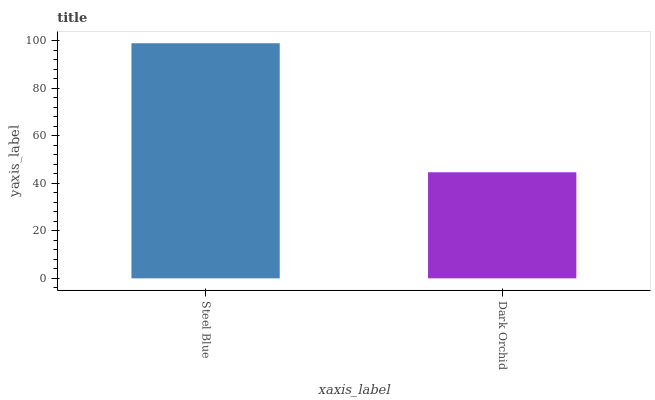Is Dark Orchid the minimum?
Answer yes or no. Yes. Is Steel Blue the maximum?
Answer yes or no. Yes. Is Dark Orchid the maximum?
Answer yes or no. No. Is Steel Blue greater than Dark Orchid?
Answer yes or no. Yes. Is Dark Orchid less than Steel Blue?
Answer yes or no. Yes. Is Dark Orchid greater than Steel Blue?
Answer yes or no. No. Is Steel Blue less than Dark Orchid?
Answer yes or no. No. Is Steel Blue the high median?
Answer yes or no. Yes. Is Dark Orchid the low median?
Answer yes or no. Yes. Is Dark Orchid the high median?
Answer yes or no. No. Is Steel Blue the low median?
Answer yes or no. No. 